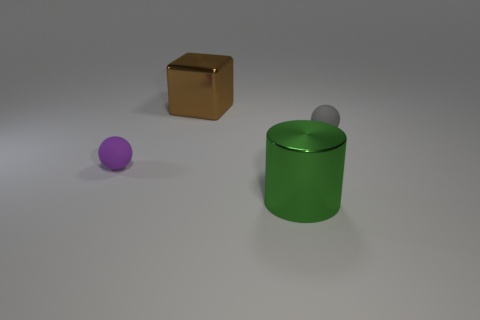Add 1 large green shiny objects. How many objects exist? 5 Subtract 1 gray balls. How many objects are left? 3 Subtract all blocks. Subtract all tiny purple spheres. How many objects are left? 2 Add 4 big things. How many big things are left? 6 Add 2 purple spheres. How many purple spheres exist? 3 